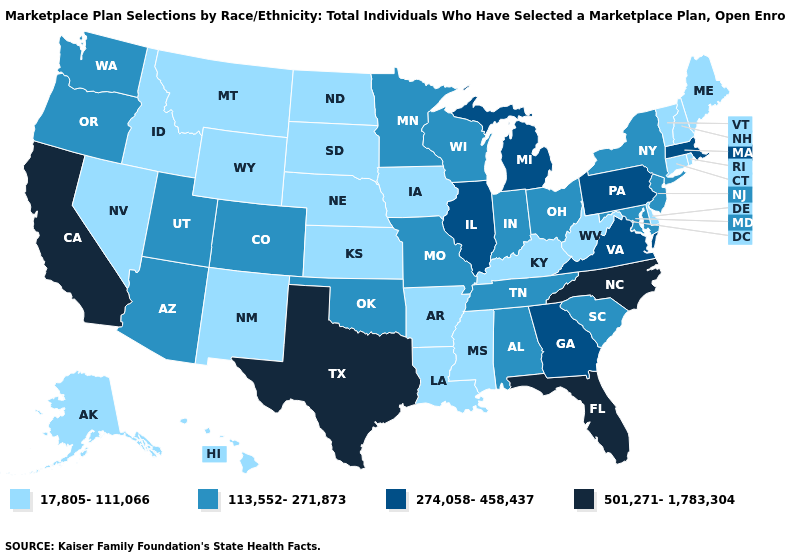Which states hav the highest value in the West?
Be succinct. California. Among the states that border Arizona , does Colorado have the lowest value?
Concise answer only. No. Does Alabama have a higher value than Delaware?
Be succinct. Yes. Which states have the lowest value in the West?
Concise answer only. Alaska, Hawaii, Idaho, Montana, Nevada, New Mexico, Wyoming. Name the states that have a value in the range 274,058-458,437?
Quick response, please. Georgia, Illinois, Massachusetts, Michigan, Pennsylvania, Virginia. What is the lowest value in states that border South Carolina?
Concise answer only. 274,058-458,437. What is the value of Maryland?
Quick response, please. 113,552-271,873. What is the value of Delaware?
Give a very brief answer. 17,805-111,066. Name the states that have a value in the range 274,058-458,437?
Short answer required. Georgia, Illinois, Massachusetts, Michigan, Pennsylvania, Virginia. What is the value of Louisiana?
Keep it brief. 17,805-111,066. Name the states that have a value in the range 501,271-1,783,304?
Concise answer only. California, Florida, North Carolina, Texas. How many symbols are there in the legend?
Concise answer only. 4. Among the states that border Montana , which have the lowest value?
Quick response, please. Idaho, North Dakota, South Dakota, Wyoming. Name the states that have a value in the range 501,271-1,783,304?
Give a very brief answer. California, Florida, North Carolina, Texas. What is the value of Nevada?
Be succinct. 17,805-111,066. 